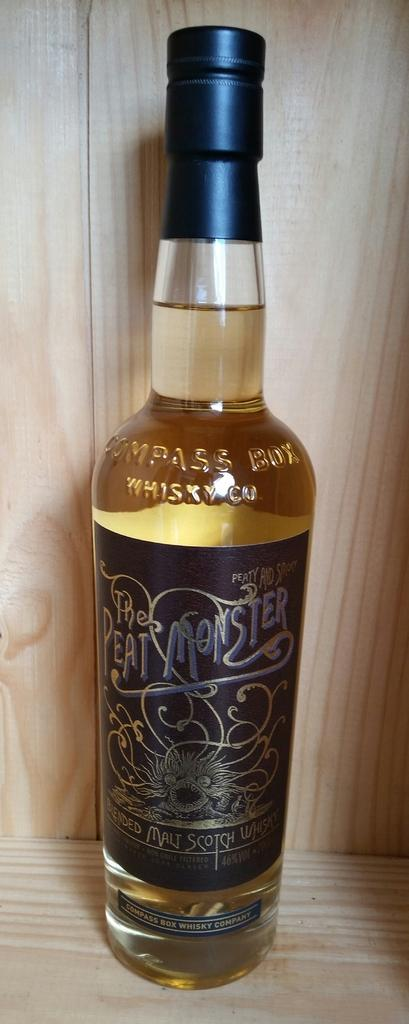<image>
Relay a brief, clear account of the picture shown. A bottle of whisky called The Peat Monster features a drawing of a monster on the label. 